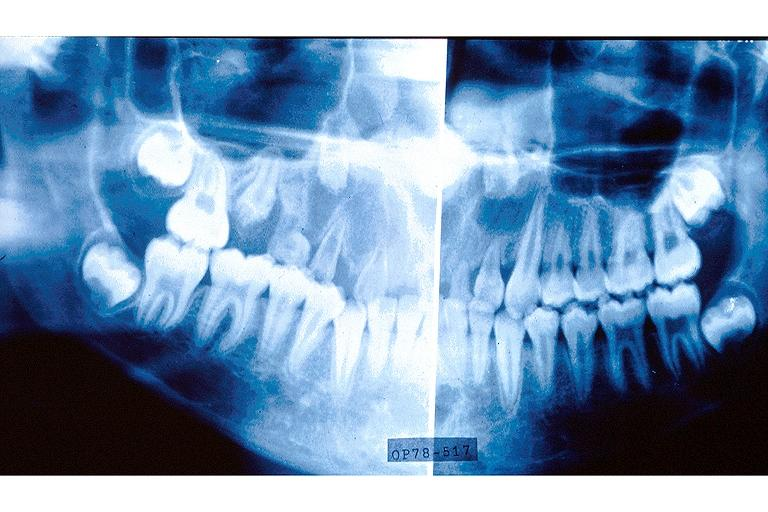does this image show regional odontodysplasia?
Answer the question using a single word or phrase. Yes 